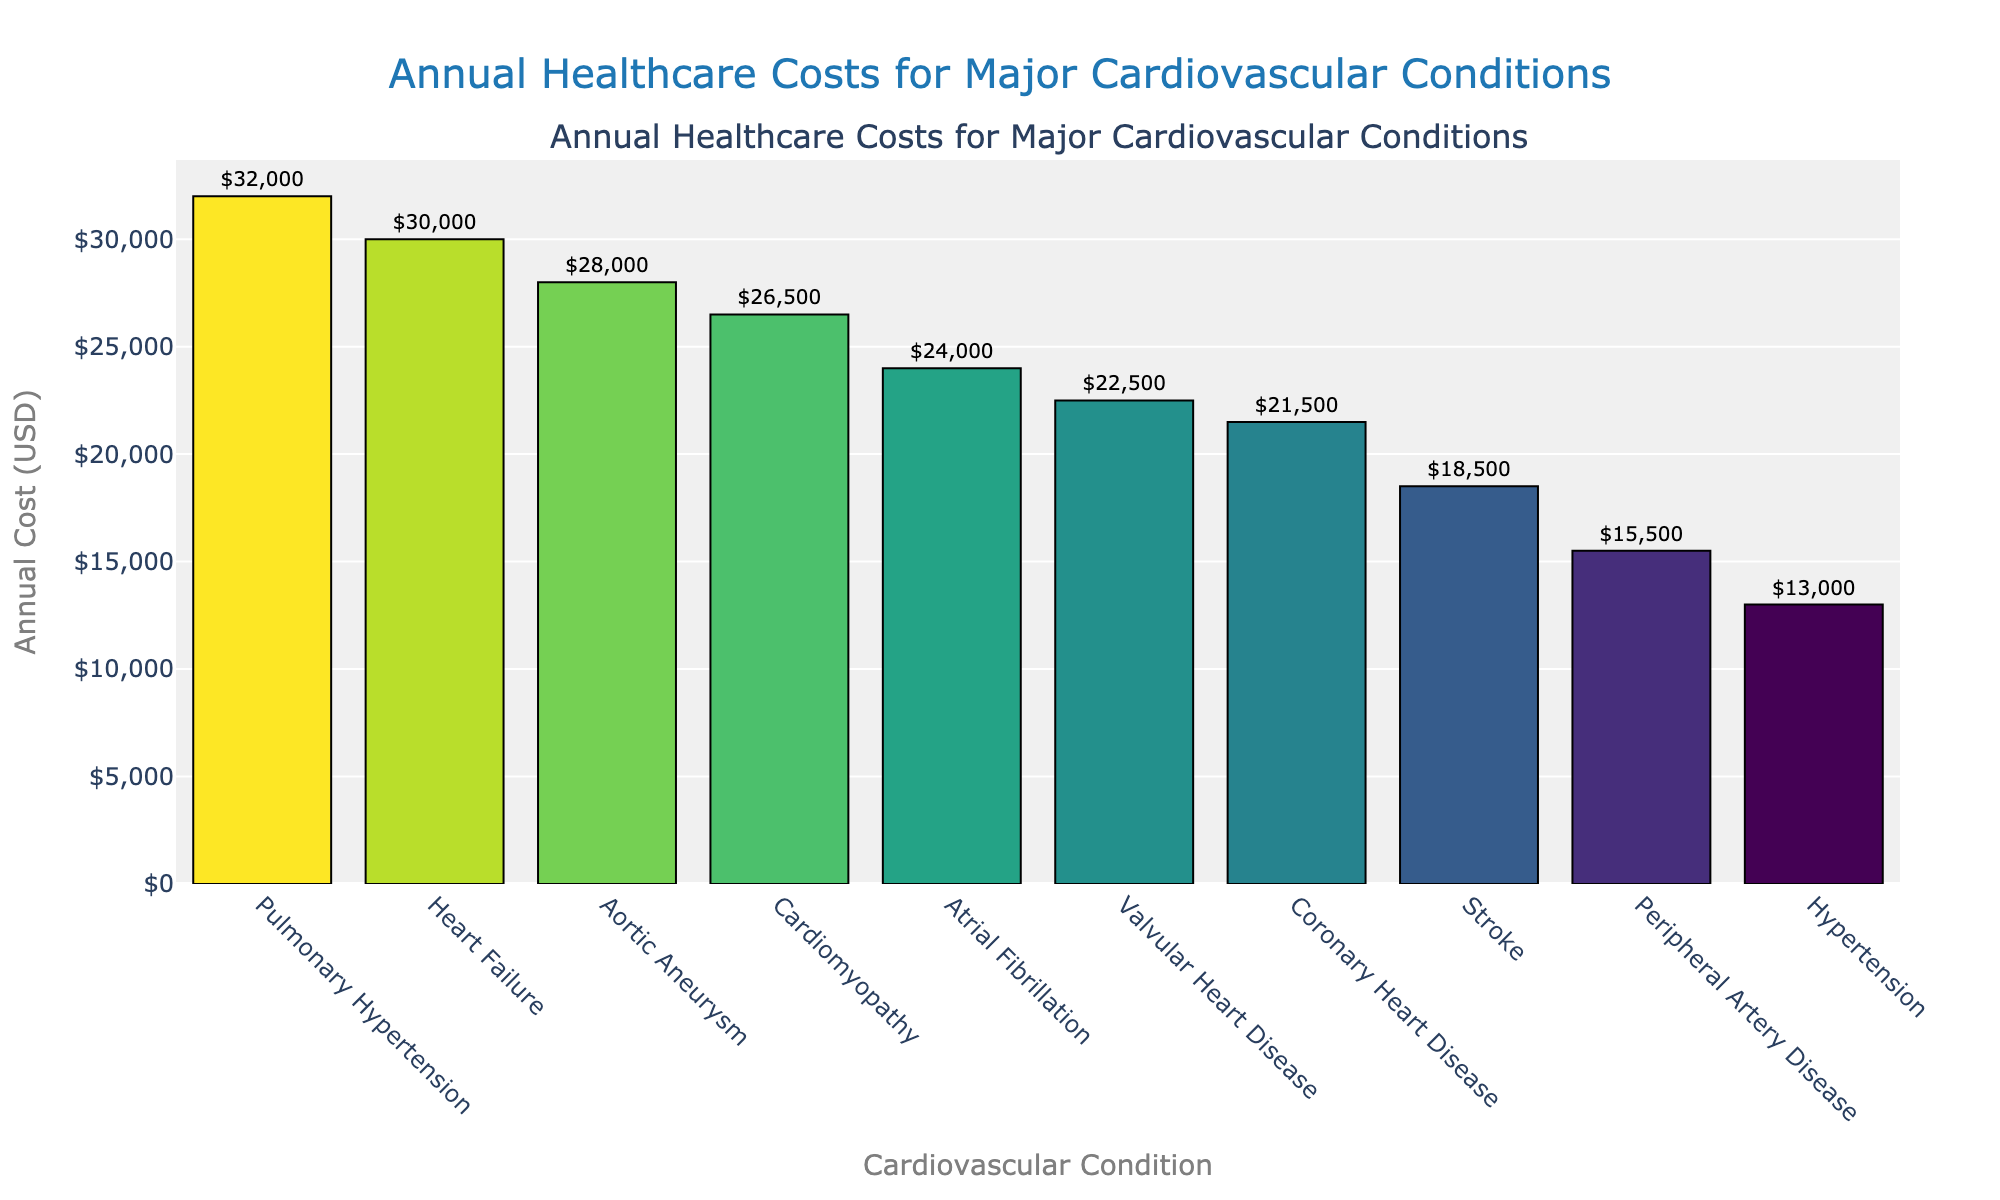Which cardiovascular condition has the highest annual healthcare cost? The tallest bar in the figure represents Pulmonary Hypertension, indicating it has the highest annual healthcare cost.
Answer: Pulmonary Hypertension What is the total annual cost for the three least expensive conditions? Sum the annual costs for Hypertension, Peripheral Artery Disease, and Stroke, which are $13,000, $15,500, and $18,500, respectively. The total is $13,000 + $15,500 + $18,500.
Answer: $47,000 How much more is spent annually on Heart Failure compared to Hypertension? Heart Failure costs $30,000, while Hypertension costs $13,000. The difference is $30,000 - $13,000.
Answer: $17,000 Which cardiovascular conditions have an annual cost between $20,000 and $25,000? The bars that fall in this range are Coronary Heart Disease at $21,500, Valvular Heart Disease at $22,500, and Atrial Fibrillation at $24,000.
Answer: Coronary Heart Disease, Valvular Heart Disease, Atrial Fibrillation What is the average annual healthcare cost for the listed cardiovascular conditions? Sum all the annual costs and divide by the number of conditions. The total sum is $240,500 and there are 10 conditions. The average is $240,500 / 10.
Answer: $24,050 Which condition has a higher cost, Aortic Aneurysm or Cardiomyopathy? Compare the heights of the bars. Aortic Aneurysm has a cost of $28,000 and Cardiomyopathy has a cost of $26,500.
Answer: Aortic Aneurysm What is the difference in annual cost between the most and least expensive conditions? The most expensive condition is Pulmonary Hypertension ($32,000) and the least expensive is Hypertension ($13,000). The difference is $32,000 - $13,000.
Answer: $19,000 Which cardiovascular conditions have costs greater than Coronary Heart Disease? The conditions that have higher bars than Coronary Heart Disease ($21,500) are Heart Failure, Aortic Aneurysm, Cardiomyopathy, Valvular Heart Disease, Atrial Fibrillation, and Pulmonary Hypertension.
Answer: Heart Failure, Aortic Aneurysm, Cardiomyopathy, Valvular Heart Disease, Atrial Fibrillation, Pulmonary Hypertension What is the median annual healthcare cost of the conditions listed? Sort the costs and find the middle value(s). Sorted costs: $13,000, $15,500, $18,500, $21,500, $22,500, $24,000, $26,500, $28,000, $30,000, $32,000. The median, being the average of the 5th and 6th values, is ($22,500 + $24,000) / 2.
Answer: $23,250 Which conditions' bars have a similar length and are adjacent to each other in the plot? Valvular Heart Disease at $22,500 and Atrial Fibrillation at $24,000 have bars of similar length and are adjacent next to each other.
Answer: Valvular Heart Disease, Atrial Fibrillation 